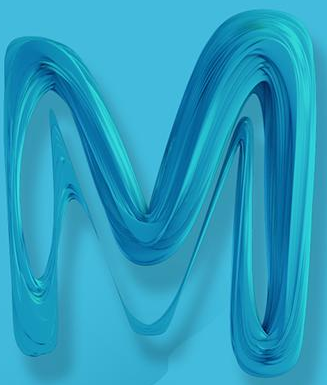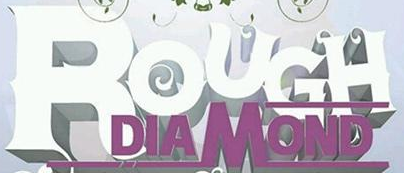Transcribe the words shown in these images in order, separated by a semicolon. M; ROUGH 